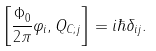Convert formula to latex. <formula><loc_0><loc_0><loc_500><loc_500>\left [ \frac { \Phi _ { 0 } } { 2 \pi } \varphi _ { i } , Q _ { C ; j } \right ] = i \hbar { \delta } _ { i j } .</formula> 